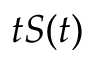Convert formula to latex. <formula><loc_0><loc_0><loc_500><loc_500>t S ( t )</formula> 